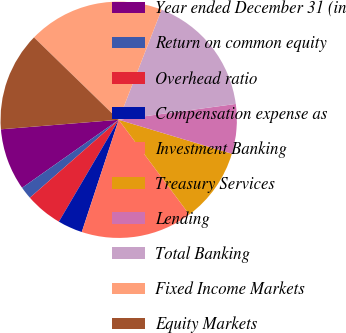<chart> <loc_0><loc_0><loc_500><loc_500><pie_chart><fcel>Year ended December 31 (in<fcel>Return on common equity<fcel>Overhead ratio<fcel>Compensation expense as<fcel>Investment Banking<fcel>Treasury Services<fcel>Lending<fcel>Total Banking<fcel>Fixed Income Markets<fcel>Equity Markets<nl><fcel>8.48%<fcel>1.7%<fcel>5.09%<fcel>3.39%<fcel>15.25%<fcel>10.17%<fcel>6.78%<fcel>16.95%<fcel>18.64%<fcel>13.56%<nl></chart> 